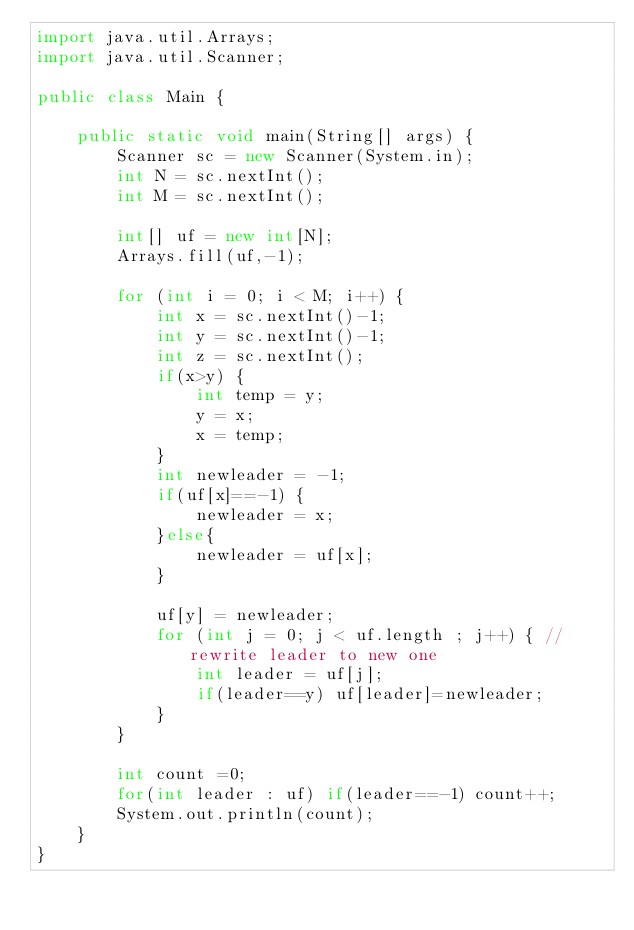<code> <loc_0><loc_0><loc_500><loc_500><_Java_>import java.util.Arrays;
import java.util.Scanner;

public class Main {

    public static void main(String[] args) {
        Scanner sc = new Scanner(System.in);
        int N = sc.nextInt();
        int M = sc.nextInt();

        int[] uf = new int[N];
        Arrays.fill(uf,-1);

        for (int i = 0; i < M; i++) {
            int x = sc.nextInt()-1;
            int y = sc.nextInt()-1;
            int z = sc.nextInt();
            if(x>y) {
                int temp = y;
                y = x;
                x = temp;
            }
            int newleader = -1;
            if(uf[x]==-1) {
                newleader = x;
            }else{
                newleader = uf[x];
            }

            uf[y] = newleader;
            for (int j = 0; j < uf.length ; j++) { // rewrite leader to new one
                int leader = uf[j];
                if(leader==y) uf[leader]=newleader;
            }
        }

        int count =0;
        for(int leader : uf) if(leader==-1) count++;
        System.out.println(count);
    }
}</code> 